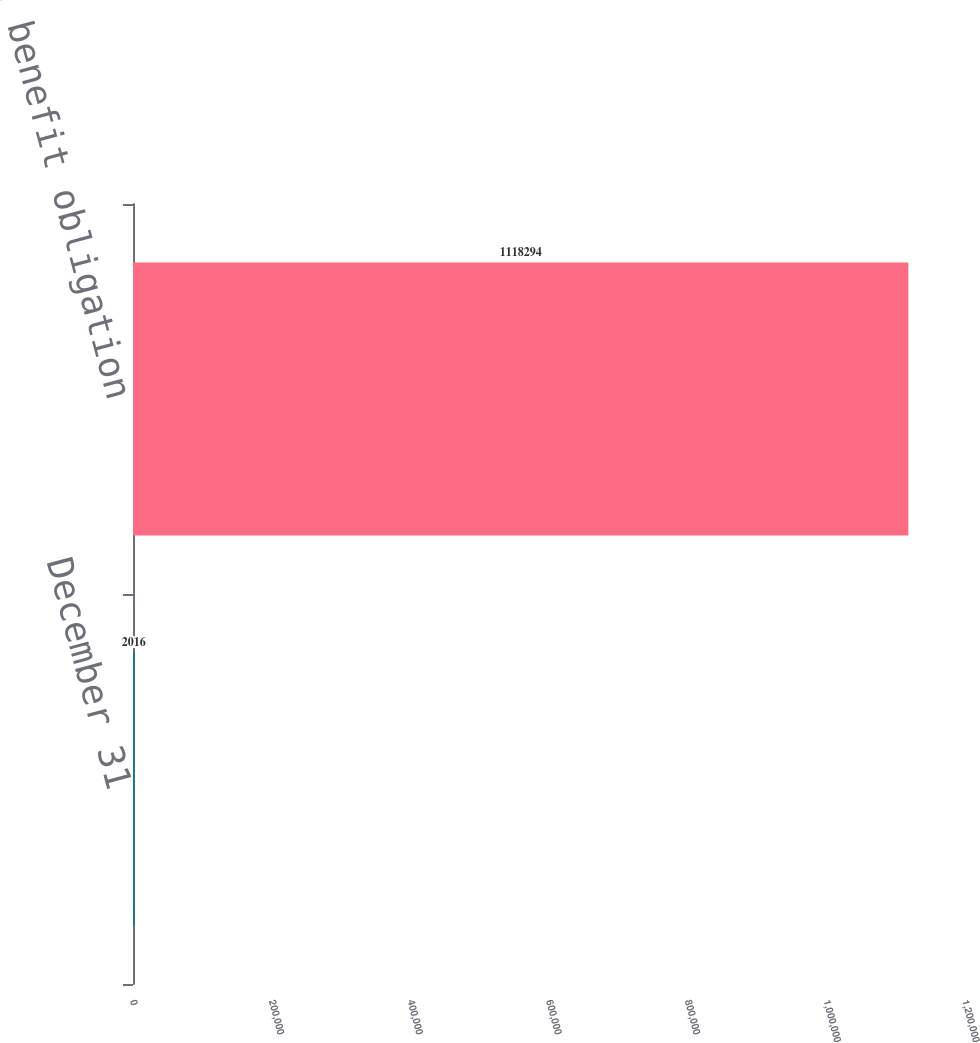Convert chart to OTSL. <chart><loc_0><loc_0><loc_500><loc_500><bar_chart><fcel>December 31<fcel>Projected benefit obligation<nl><fcel>2016<fcel>1.11829e+06<nl></chart> 